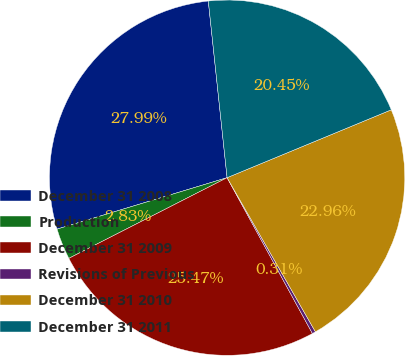Convert chart. <chart><loc_0><loc_0><loc_500><loc_500><pie_chart><fcel>December 31 2008<fcel>Production<fcel>December 31 2009<fcel>Revisions of Previous<fcel>December 31 2010<fcel>December 31 2011<nl><fcel>27.99%<fcel>2.83%<fcel>25.47%<fcel>0.31%<fcel>22.96%<fcel>20.45%<nl></chart> 